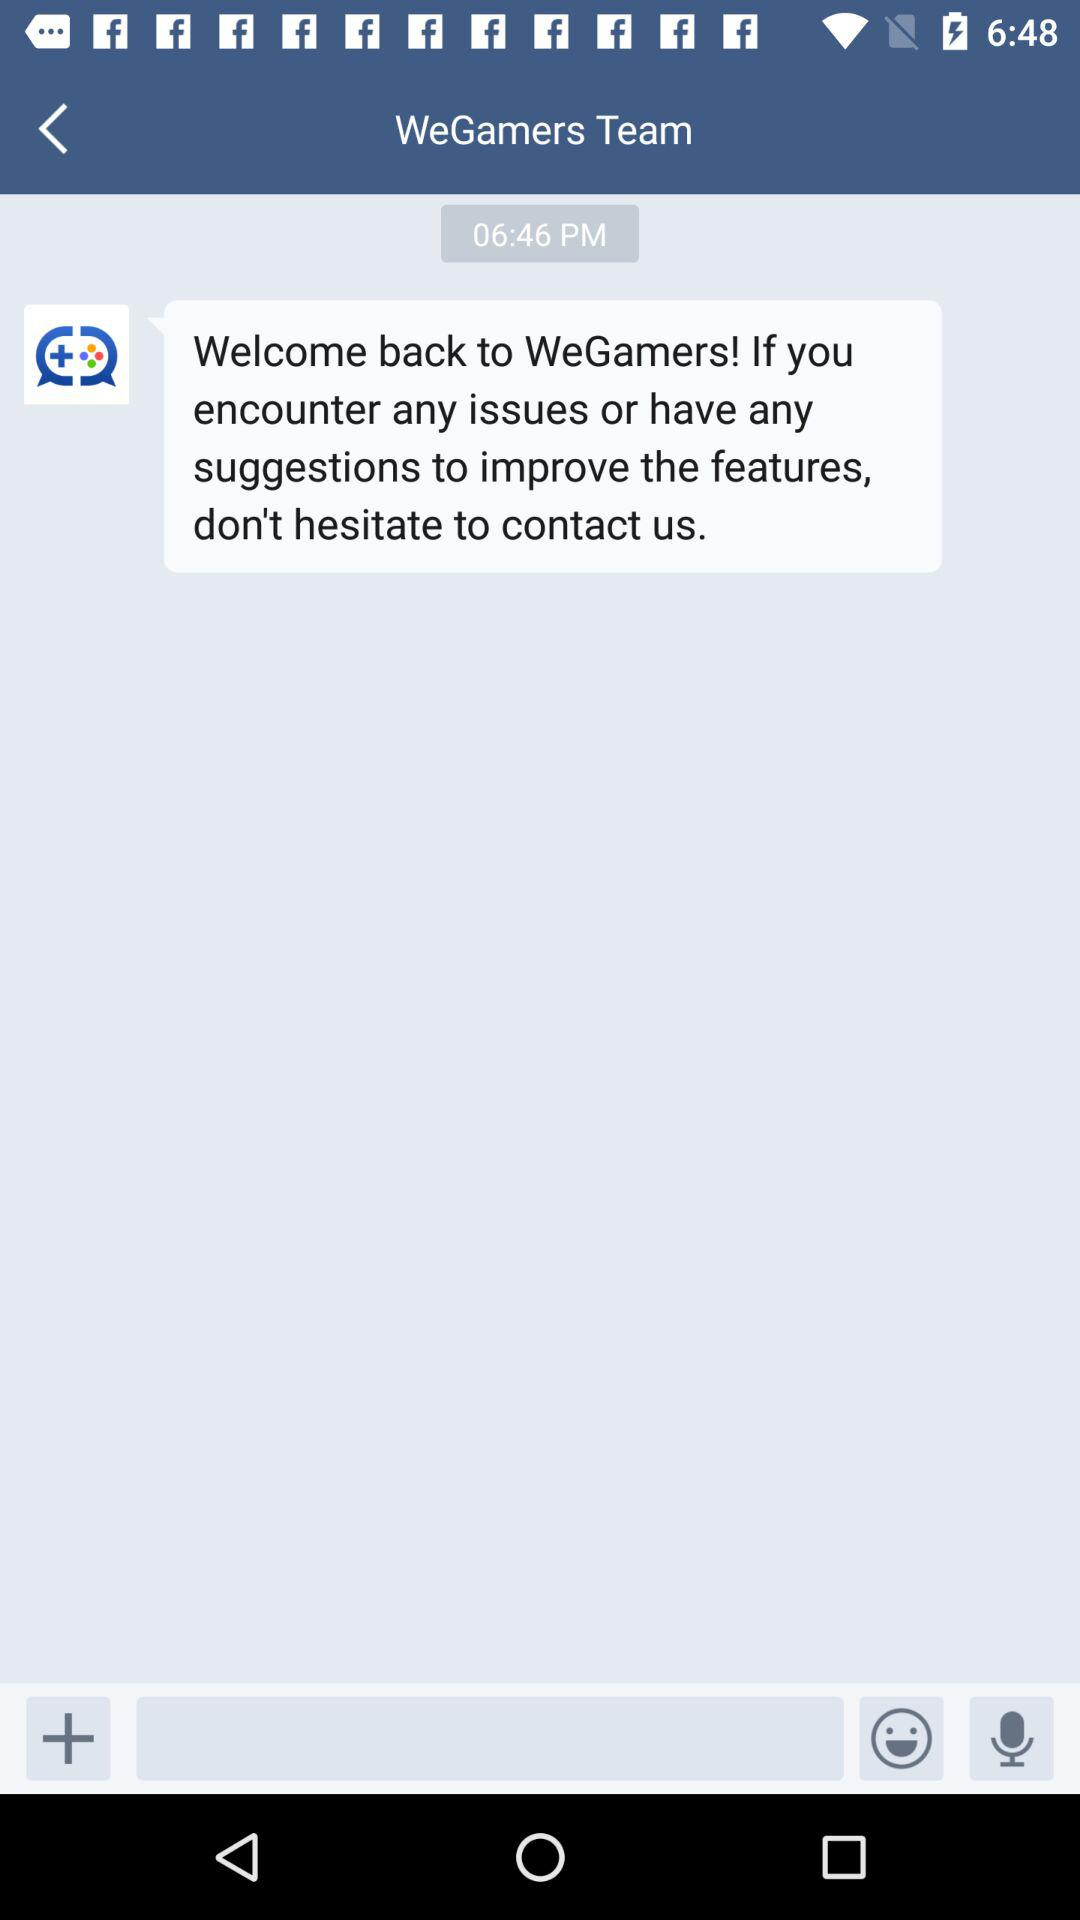What is the time? The time is 06:46 PM. 